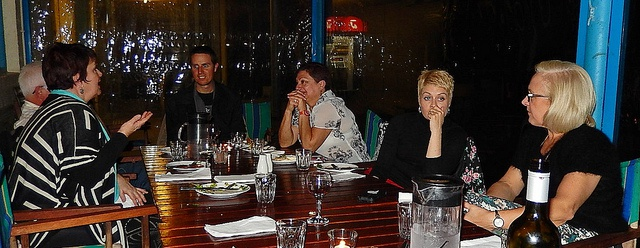Describe the objects in this image and their specific colors. I can see dining table in navy, black, maroon, gray, and darkgray tones, people in navy, black, darkgray, brown, and lightgray tones, people in navy, black, gray, and tan tones, people in navy, black, gray, and tan tones, and people in navy, darkgray, black, and brown tones in this image. 